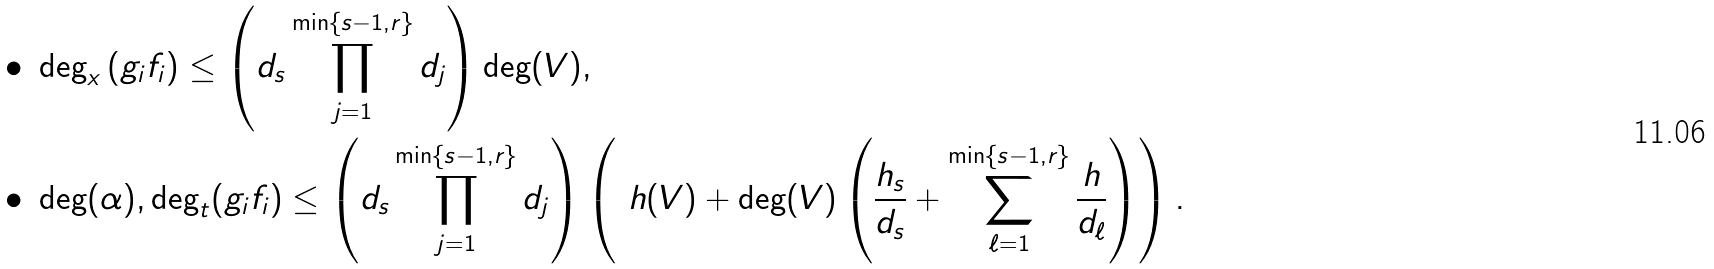Convert formula to latex. <formula><loc_0><loc_0><loc_500><loc_500>\bullet & \ \deg _ { x } \left ( g _ { i } f _ { i } \right ) \leq \left ( d _ { s } \prod _ { j = 1 } ^ { \min \{ s - 1 , r \} } d _ { j } \right ) \deg ( V ) , \\ \bullet & \ \deg ( \alpha ) , \deg _ { t } ( g _ { i } f _ { i } ) \leq \left ( d _ { s } \prod _ { j = 1 } ^ { \min \{ s - 1 , r \} } d _ { j } \right ) \left ( \ h ( V ) + \deg ( V ) \left ( \frac { h _ { s } } { d _ { s } } + \sum _ { \ell = 1 } ^ { \min \{ s - 1 , r \} } \frac { h } { d _ { \ell } } \right ) \right ) .</formula> 